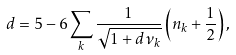<formula> <loc_0><loc_0><loc_500><loc_500>d = 5 - 6 \sum _ { k } \frac { 1 } { \sqrt { 1 + d \nu _ { k } } } \left ( n _ { k } + \frac { 1 } { 2 } \right ) ,</formula> 